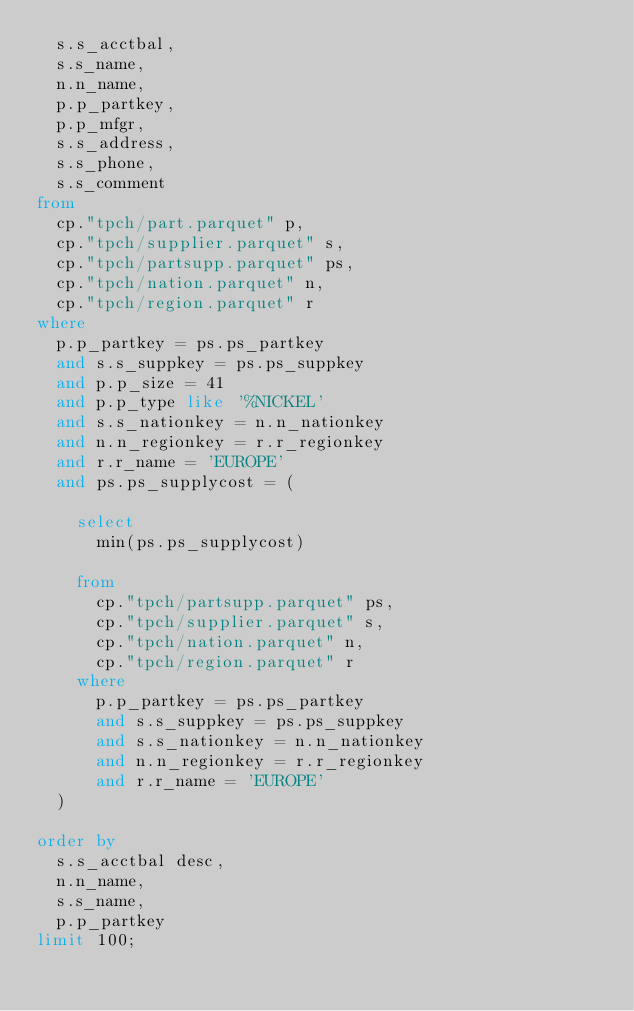<code> <loc_0><loc_0><loc_500><loc_500><_SQL_>  s.s_acctbal,
  s.s_name,
  n.n_name,
  p.p_partkey,
  p.p_mfgr,
  s.s_address,
  s.s_phone,
  s.s_comment
from
  cp."tpch/part.parquet" p,
  cp."tpch/supplier.parquet" s,
  cp."tpch/partsupp.parquet" ps,
  cp."tpch/nation.parquet" n,
  cp."tpch/region.parquet" r
where
  p.p_partkey = ps.ps_partkey
  and s.s_suppkey = ps.ps_suppkey
  and p.p_size = 41
  and p.p_type like '%NICKEL'
  and s.s_nationkey = n.n_nationkey
  and n.n_regionkey = r.r_regionkey
  and r.r_name = 'EUROPE'
  and ps.ps_supplycost = (

    select
      min(ps.ps_supplycost)

    from
      cp."tpch/partsupp.parquet" ps,
      cp."tpch/supplier.parquet" s,
      cp."tpch/nation.parquet" n,
      cp."tpch/region.parquet" r
    where
      p.p_partkey = ps.ps_partkey
      and s.s_suppkey = ps.ps_suppkey
      and s.s_nationkey = n.n_nationkey
      and n.n_regionkey = r.r_regionkey
      and r.r_name = 'EUROPE'
  )

order by
  s.s_acctbal desc,
  n.n_name,
  s.s_name,
  p.p_partkey
limit 100;</code> 